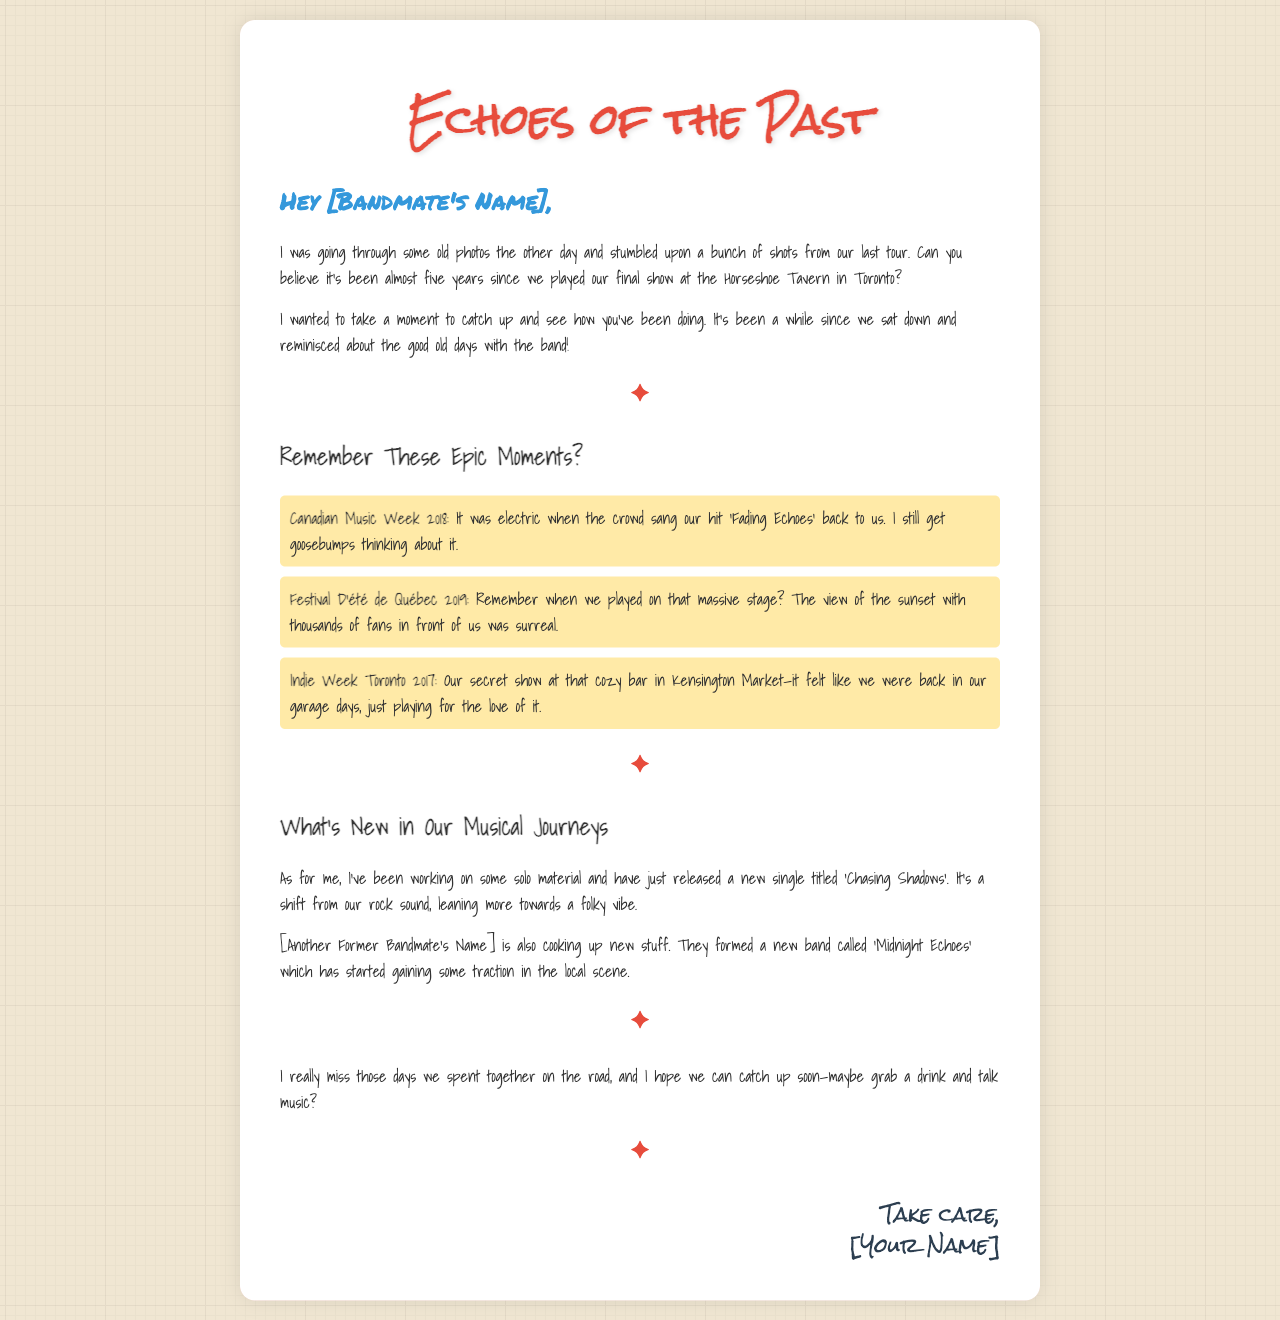What was the name of the last show played by the band? The letter mentions that the last show was played at the Horseshoe Tavern in Toronto.
Answer: Horseshoe Tavern How many years has it been since their final show? The writer mentions it has been almost five years since the final show.
Answer: five years What song did the crowd sing back to the band during Canadian Music Week 2018? The letter states that the crowd sang their hit 'Fading Echoes' back to them.
Answer: Fading Echoes What is the title of the writer's new single? The writer mentions releasing a new single titled 'Chasing Shadows'.
Answer: Chasing Shadows What genre shift does the writer mention in their new music? The writer indicates a shift towards a more folky vibe in their solo material.
Answer: folky Which festival did they play in 2019? The letter references the Festival D'été de Québec that they played in 2019.
Answer: Festival D'été de Québec What was the name of the new band formed by another former bandmate? According to the letter, the new band created by another former bandmate is called 'Midnight Echoes'.
Answer: Midnight Echoes What location did the secret show take place in 2017? The writer reminisces about a secret show at a cozy bar in Kensington Market during Indie Week Toronto 2017.
Answer: Kensington Market What does the writer miss from their band days? The writer expresses missing the days spent together on the road.
Answer: days on the road 